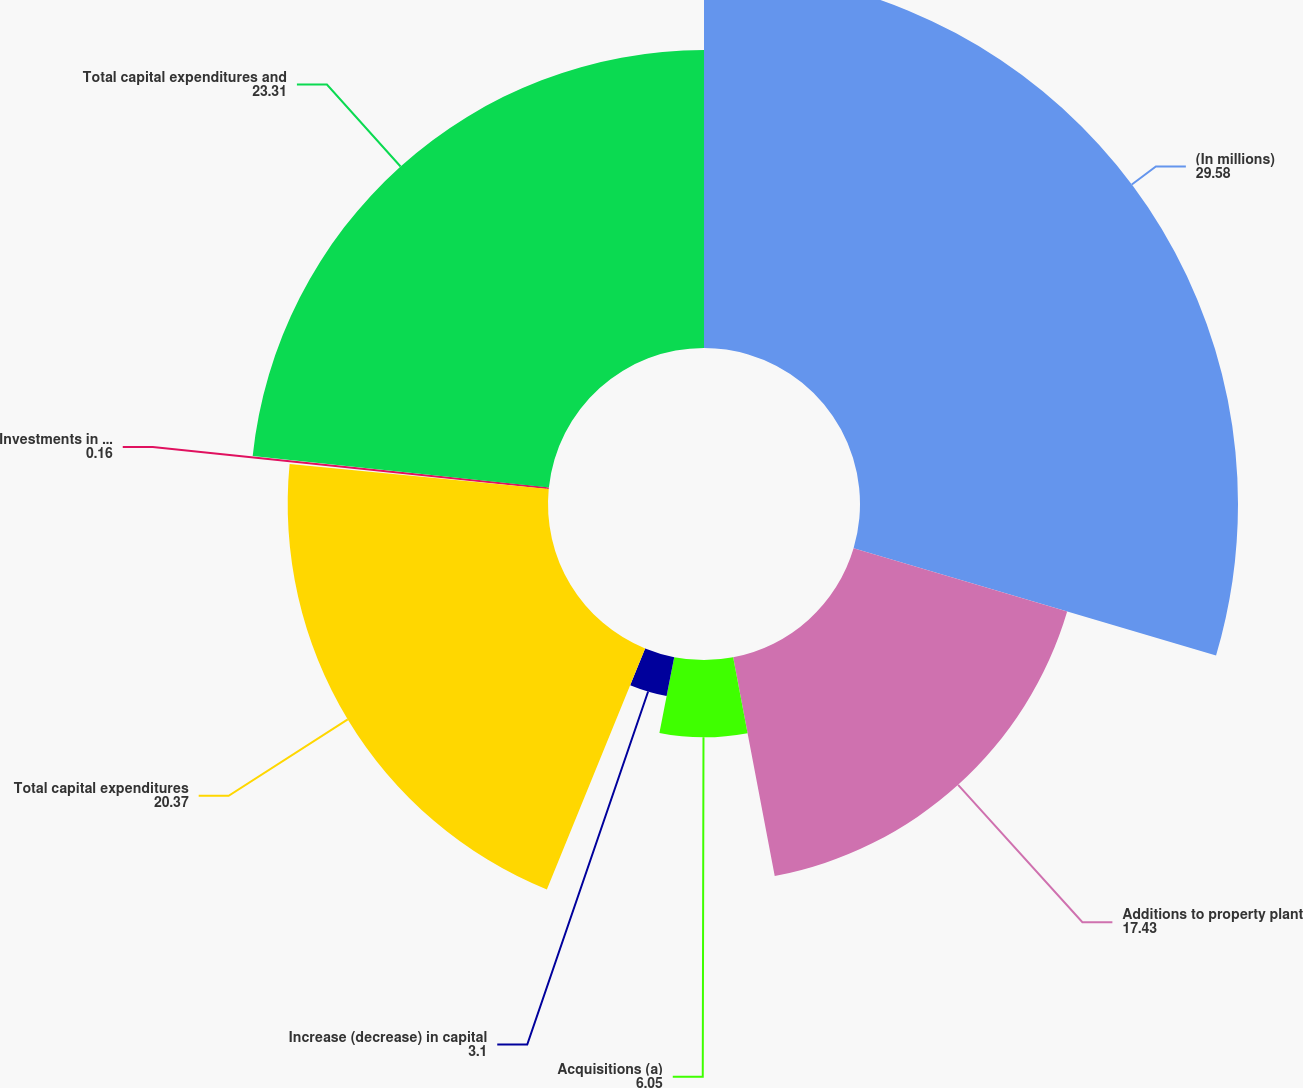Convert chart. <chart><loc_0><loc_0><loc_500><loc_500><pie_chart><fcel>(In millions)<fcel>Additions to property plant<fcel>Acquisitions (a)<fcel>Increase (decrease) in capital<fcel>Total capital expenditures<fcel>Investments in equity method<fcel>Total capital expenditures and<nl><fcel>29.58%<fcel>17.43%<fcel>6.05%<fcel>3.1%<fcel>20.37%<fcel>0.16%<fcel>23.31%<nl></chart> 